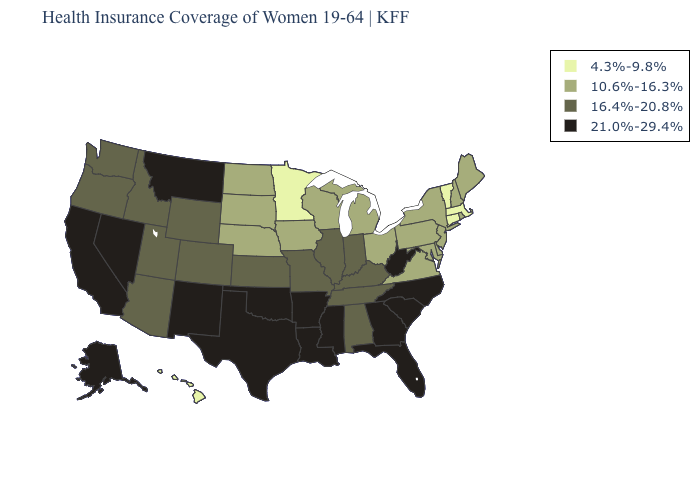Does Kansas have a lower value than Florida?
Quick response, please. Yes. What is the value of Florida?
Concise answer only. 21.0%-29.4%. Name the states that have a value in the range 10.6%-16.3%?
Short answer required. Delaware, Iowa, Maine, Maryland, Michigan, Nebraska, New Hampshire, New Jersey, New York, North Dakota, Ohio, Pennsylvania, Rhode Island, South Dakota, Virginia, Wisconsin. What is the lowest value in states that border Maine?
Quick response, please. 10.6%-16.3%. Which states have the lowest value in the USA?
Be succinct. Connecticut, Hawaii, Massachusetts, Minnesota, Vermont. Does the map have missing data?
Be succinct. No. What is the value of New Jersey?
Keep it brief. 10.6%-16.3%. What is the highest value in the South ?
Be succinct. 21.0%-29.4%. What is the value of New Hampshire?
Write a very short answer. 10.6%-16.3%. What is the value of Virginia?
Be succinct. 10.6%-16.3%. How many symbols are there in the legend?
Short answer required. 4. Does New Mexico have the highest value in the West?
Concise answer only. Yes. What is the lowest value in the USA?
Answer briefly. 4.3%-9.8%. What is the value of Utah?
Quick response, please. 16.4%-20.8%. Does the map have missing data?
Quick response, please. No. 